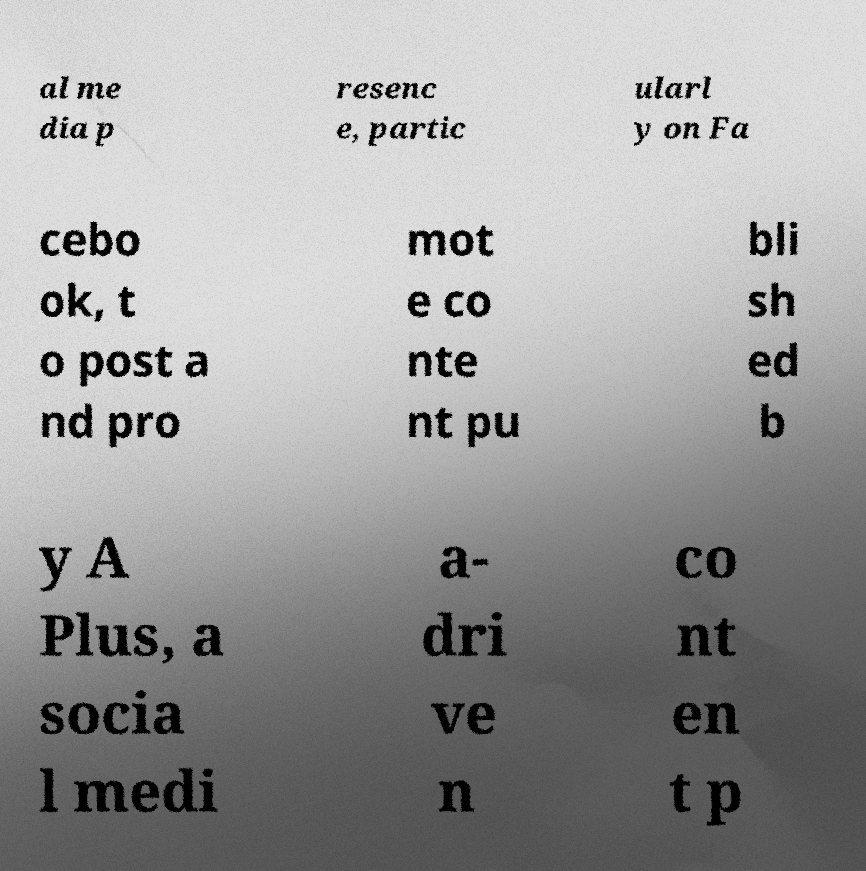Can you accurately transcribe the text from the provided image for me? al me dia p resenc e, partic ularl y on Fa cebo ok, t o post a nd pro mot e co nte nt pu bli sh ed b y A Plus, a socia l medi a- dri ve n co nt en t p 